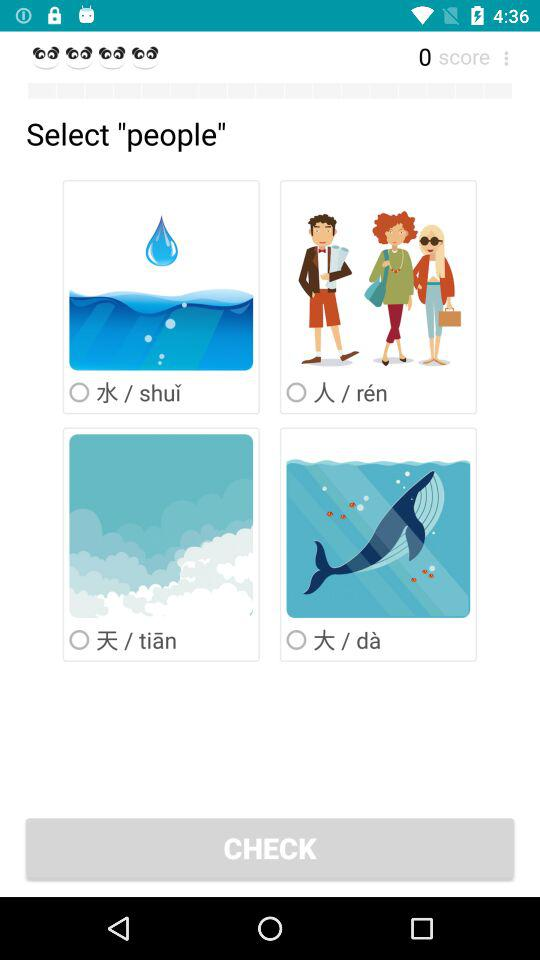What is the score? The score is 0. 